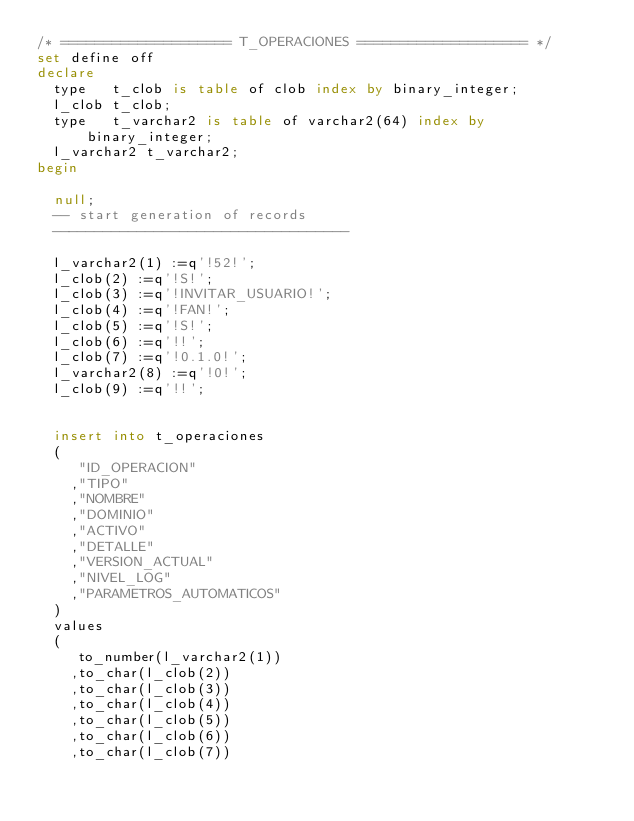Convert code to text. <code><loc_0><loc_0><loc_500><loc_500><_SQL_>/* ==================== T_OPERACIONES ==================== */
set define off
declare
  type   t_clob is table of clob index by binary_integer;
  l_clob t_clob;
  type   t_varchar2 is table of varchar2(64) index by binary_integer;
  l_varchar2 t_varchar2;
begin

  null;
  -- start generation of records
  -----------------------------------

  l_varchar2(1) :=q'!52!';
  l_clob(2) :=q'!S!';
  l_clob(3) :=q'!INVITAR_USUARIO!';
  l_clob(4) :=q'!FAN!';
  l_clob(5) :=q'!S!';
  l_clob(6) :=q'!!';
  l_clob(7) :=q'!0.1.0!';
  l_varchar2(8) :=q'!0!';
  l_clob(9) :=q'!!';

  insert into t_operaciones
  (
     "ID_OPERACION"
    ,"TIPO"
    ,"NOMBRE"
    ,"DOMINIO"
    ,"ACTIVO"
    ,"DETALLE"
    ,"VERSION_ACTUAL"
    ,"NIVEL_LOG"
    ,"PARAMETROS_AUTOMATICOS"
  )
  values
  (
     to_number(l_varchar2(1))
    ,to_char(l_clob(2))
    ,to_char(l_clob(3))
    ,to_char(l_clob(4))
    ,to_char(l_clob(5))
    ,to_char(l_clob(6))
    ,to_char(l_clob(7))</code> 